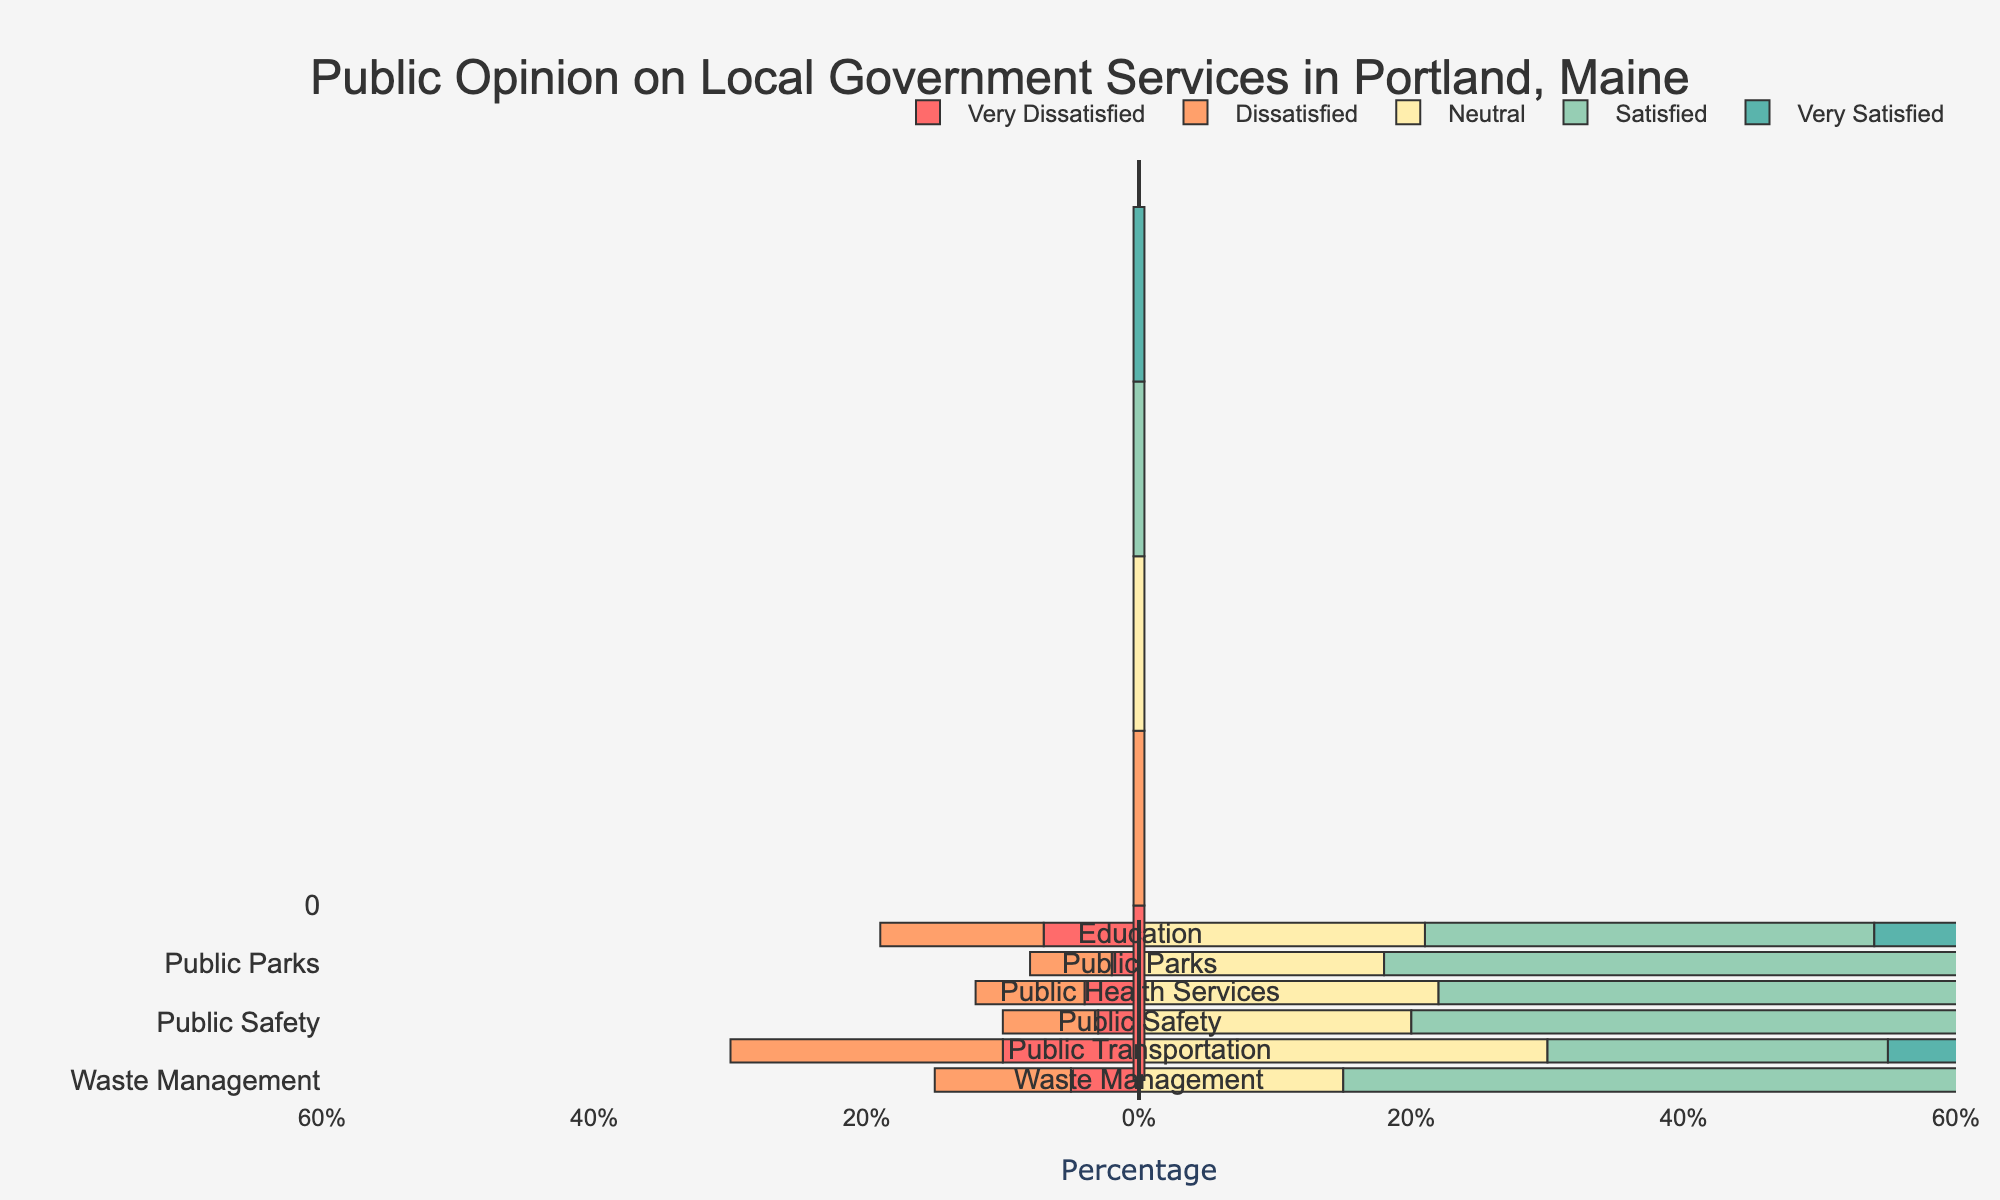What is the percentage of people who are satisfied with waste management? The satisfied percentage for waste management is the length of the bar for "Satisfied" in the waste management row. The bar represents 50% of the respondents.
Answer: 50% Which service has the highest percentage of "Very Satisfied" responses? By comparing the lengths of the darkest green bars, public safety has the highest percentage of "Very Satisfied" responses at 25%.
Answer: Public Safety How does the percentage of people who are very dissatisfied with public safety compare to waste management? The very dissatisfied percentage for public safety is 3% and for waste management is 5%. This means public safety has a lower percentage of very dissatisfied respondents by 2%.
Answer: Public Safety is 2% lower What is the total combined percentage of satisfied and very satisfied responses for public parks? The percentages of satisfied and very satisfied for public parks are 54% and 20%, respectively. Adding these gives 74%.
Answer: 74% Rank the services from highest to lowest based on the percentage of neutral responses. The percentages of neutral responses are:
- Waste Management: 15%
- Public Transportation: 30%
- Public Safety: 20%
- Public Health Services: 22%
- Public Parks: 18%
- Education: 21%
So the rank from highest to lowest is:
1. Public Transportation (30%)
2. Public Health Services (22%)
3. Education (21%)
4. Public Safety (20%)
5. Public Parks (18%)
6. Waste Management (15%)
Answer: 1. Public Transportation, 2. Public Health Services, 3. Education, 4. Public Safety, 5. Public Parks, 6. Waste Management Which service has the smallest percentage of dissatisfied and very dissatisfied responses? By comparing the sum of red and orange bars across each service, public parks have the smallest combined percentage of dissatisfied and very dissatisfied responses at 8%.
Answer: Public Parks What is the difference in the percentage of very satisfied responses between education and public transportation? The percentage of very satisfied responses for education is 27% and for public transportation is 15%. The difference is 12%.
Answer: 12% Among the services surveyed, which one has the least polarizing opinions (i.e., smallest difference between total satisfied and total dissatisfied responses)? Polarizing opinions are seen where the combined percentages of satisfied (light green + green) and dissatisfied (red + orange) are closest. For public transportation, satisfied (25% + 15%) = 40% and dissatisfied (10% + 20%) = 30%. The difference is 10%, the smallest among all other services.
Answer: Public Transportation 